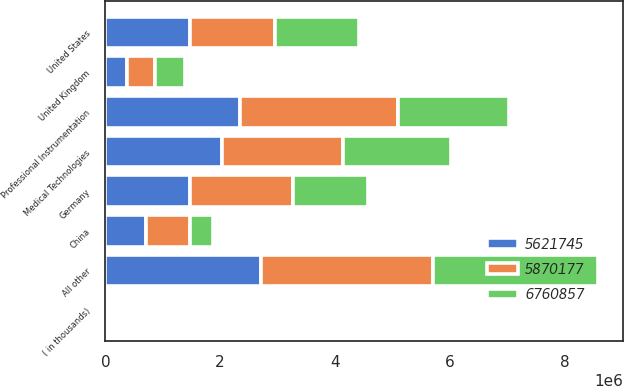Convert chart. <chart><loc_0><loc_0><loc_500><loc_500><stacked_bar_chart><ecel><fcel>( in thousands)<fcel>United States<fcel>Germany<fcel>China<fcel>United Kingdom<fcel>All other<fcel>Professional Instrumentation<fcel>Medical Technologies<nl><fcel>5.62174e+06<fcel>2009<fcel>1.47546e+06<fcel>1.47546e+06<fcel>702259<fcel>379013<fcel>2.70855e+06<fcel>2.34327e+06<fcel>2.02988e+06<nl><fcel>5.87018e+06<fcel>2008<fcel>1.47546e+06<fcel>1.7994e+06<fcel>771881<fcel>485823<fcel>2.99375e+06<fcel>2.75846e+06<fcel>2.1029e+06<nl><fcel>6.76086e+06<fcel>2007<fcel>1.47546e+06<fcel>1.29462e+06<fcel>397246<fcel>517495<fcel>2.88826e+06<fcel>1.93551e+06<fcel>1.88452e+06<nl></chart> 